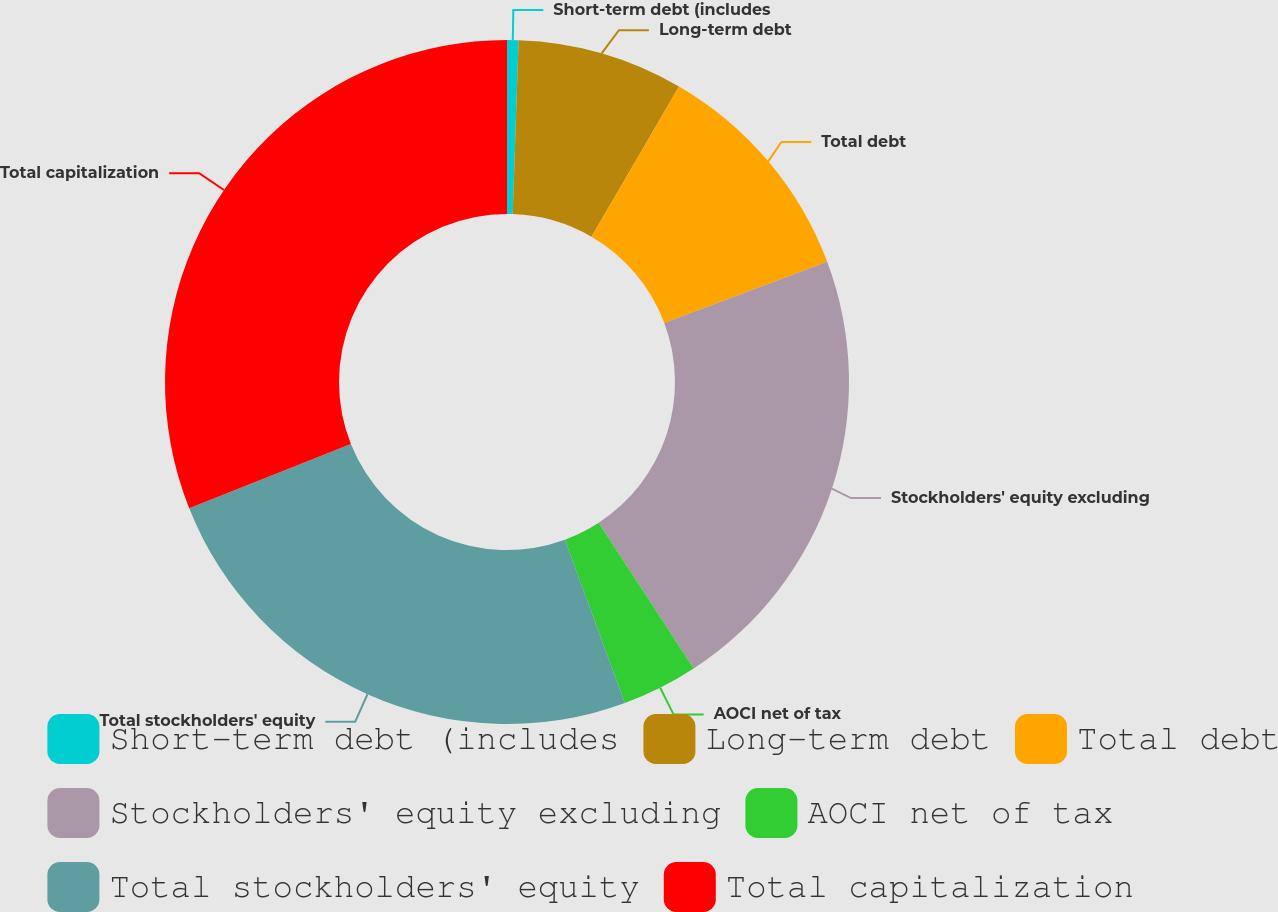<chart> <loc_0><loc_0><loc_500><loc_500><pie_chart><fcel>Short-term debt (includes<fcel>Long-term debt<fcel>Total debt<fcel>Stockholders' equity excluding<fcel>AOCI net of tax<fcel>Total stockholders' equity<fcel>Total capitalization<nl><fcel>0.54%<fcel>7.85%<fcel>10.9%<fcel>21.53%<fcel>3.59%<fcel>24.58%<fcel>31.03%<nl></chart> 